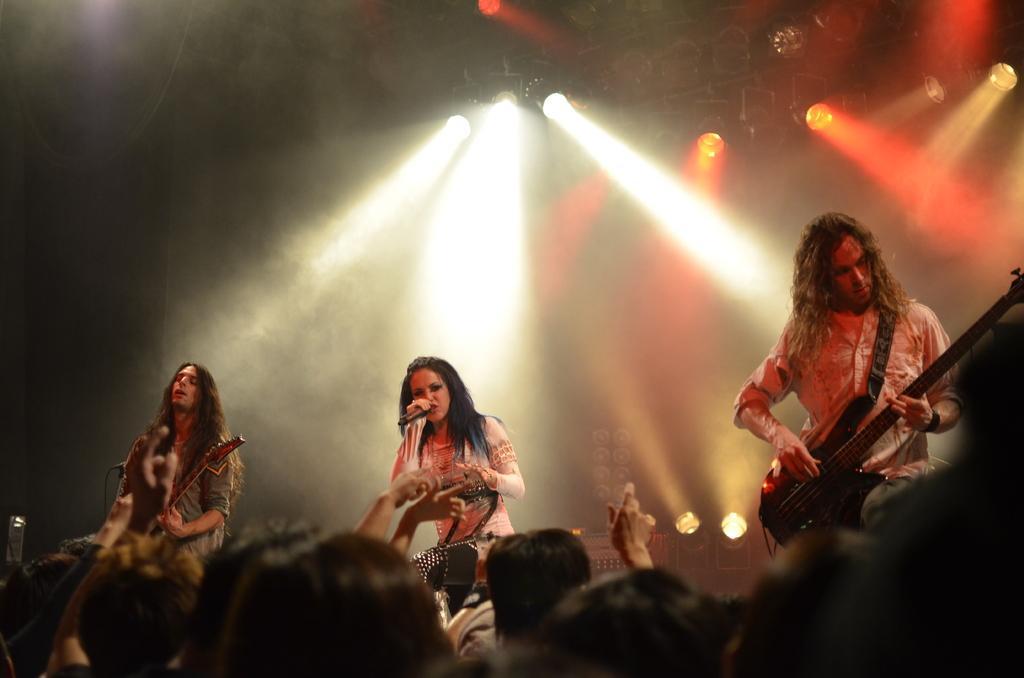Could you give a brief overview of what you see in this image? There are people standing on a stage playing a guitar and one woman is singing on the microphone. 